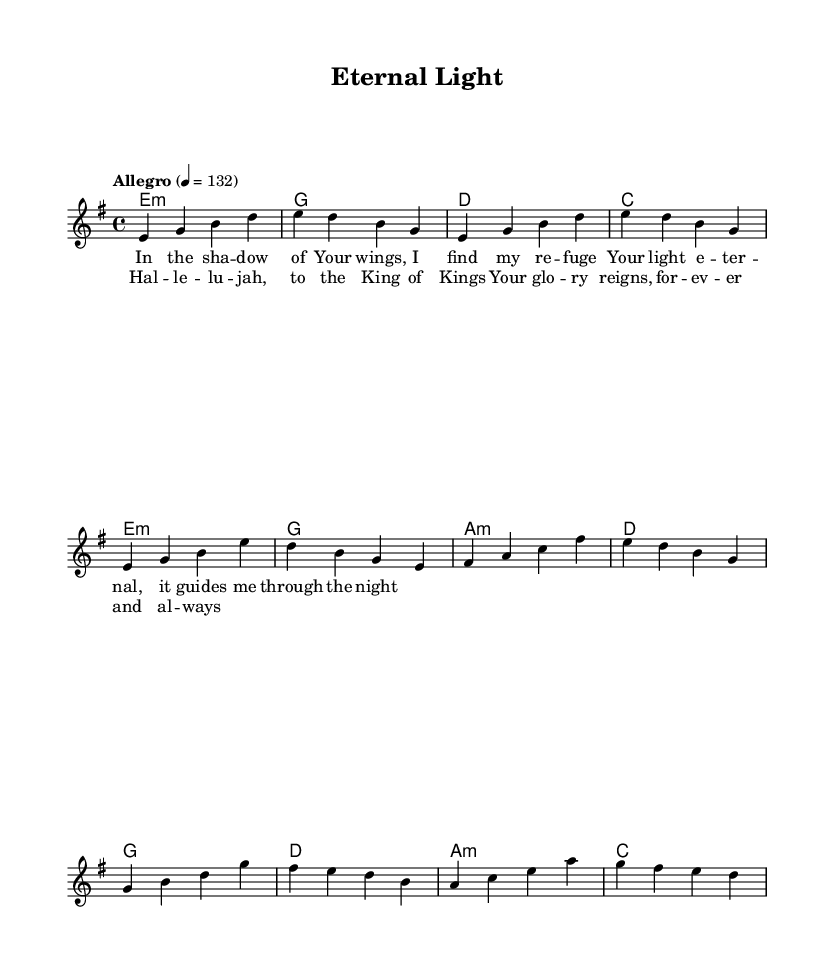What is the key signature of this music? The key signature is E minor, which has one sharp (F#) and indicates the presence of the tonic note, E.
Answer: E minor What is the time signature of the piece? The time signature is 4/4, which means there are four beats per measure. This is common in many styles of music, allowing for a steady rhythm.
Answer: 4/4 What is the tempo marking for this piece? The tempo marking indicates "Allegro," which means to play at a fast, lively pace. The specified quarter note equals 132 beats per minute gives a precise tempo indication.
Answer: Allegro How many measures are in the verse section? By counting the measures specifically indicated for the verse in the score, there are four measures before it transitions to the chorus.
Answer: 4 What is the primary lyrical theme reflected in this music? The themes of refuge, guidance, and eternal light are present in the lyrics, reflecting a strong Christian message of finding solace in faith.
Answer: Refuge and guidance Which voice part is responsible for the melody in this piece? The melody is notated in the "lead" voice part, clearly indicating where the main vocal line is situated within the score.
Answer: Lead What musical structure is utilized in this metal piece? The piece follows a verse-chorus structure, alternating between lyrical sections that emphasize both narrative and a powerful refrain, common in symphonic metal.
Answer: Verse-chorus 